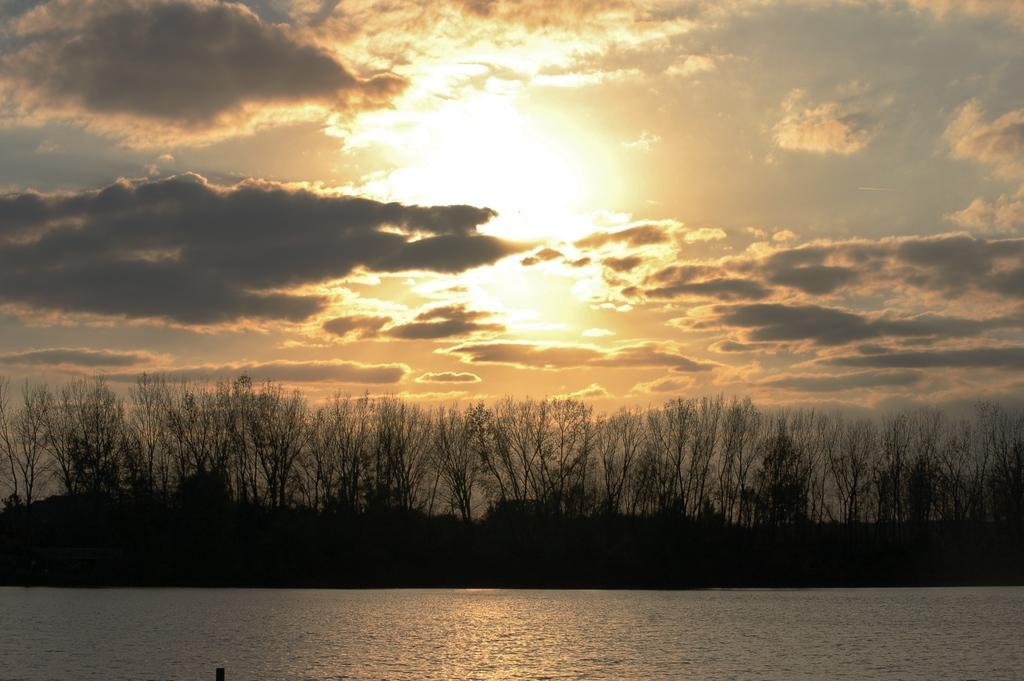What is visible in the image? Water is visible in the image. What can be seen in the background of the image? There are trees in the background of the image. How would you describe the sky in the image? The sky is cloudy in the image. What position does the stick hold in the image? There is no stick present in the image. How does the health of the trees in the background appear in the image? The provided facts do not mention the health of the trees, so it cannot be determined from the image. 